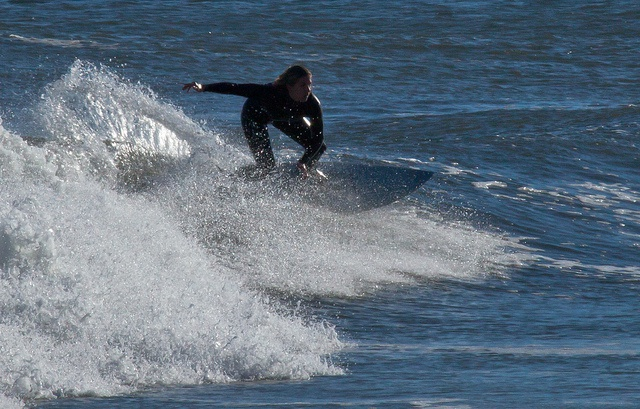Describe the objects in this image and their specific colors. I can see people in blue, black, and gray tones and surfboard in blue, gray, darkblue, and navy tones in this image. 